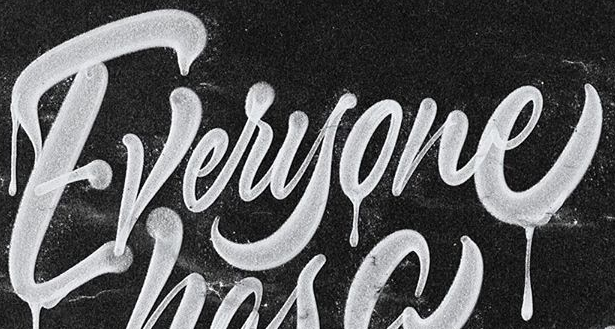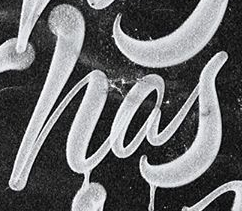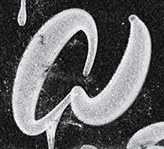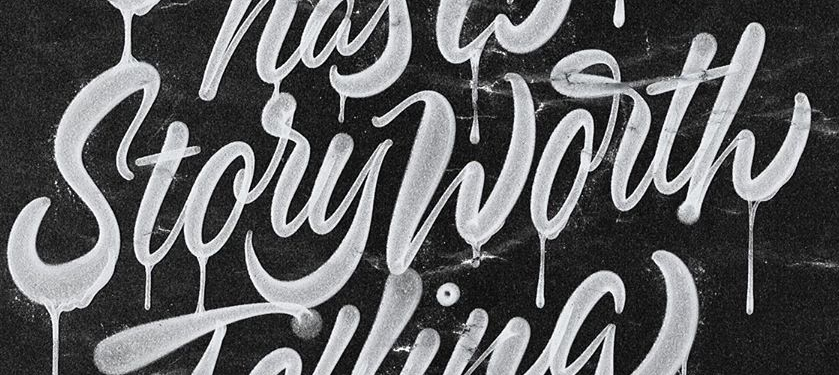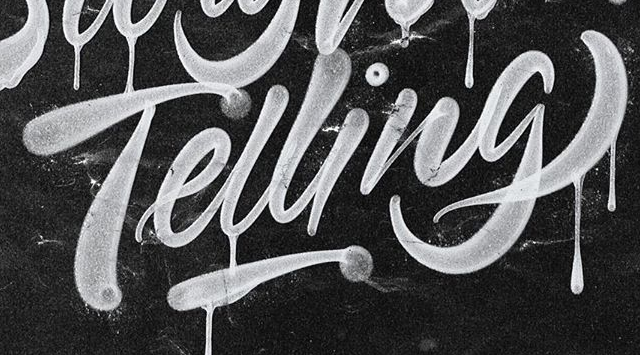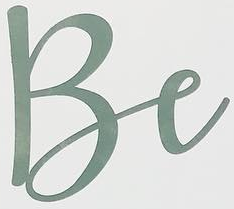What words are shown in these images in order, separated by a semicolon? Everyone; has; a; StoryWorth; Telling; Be 